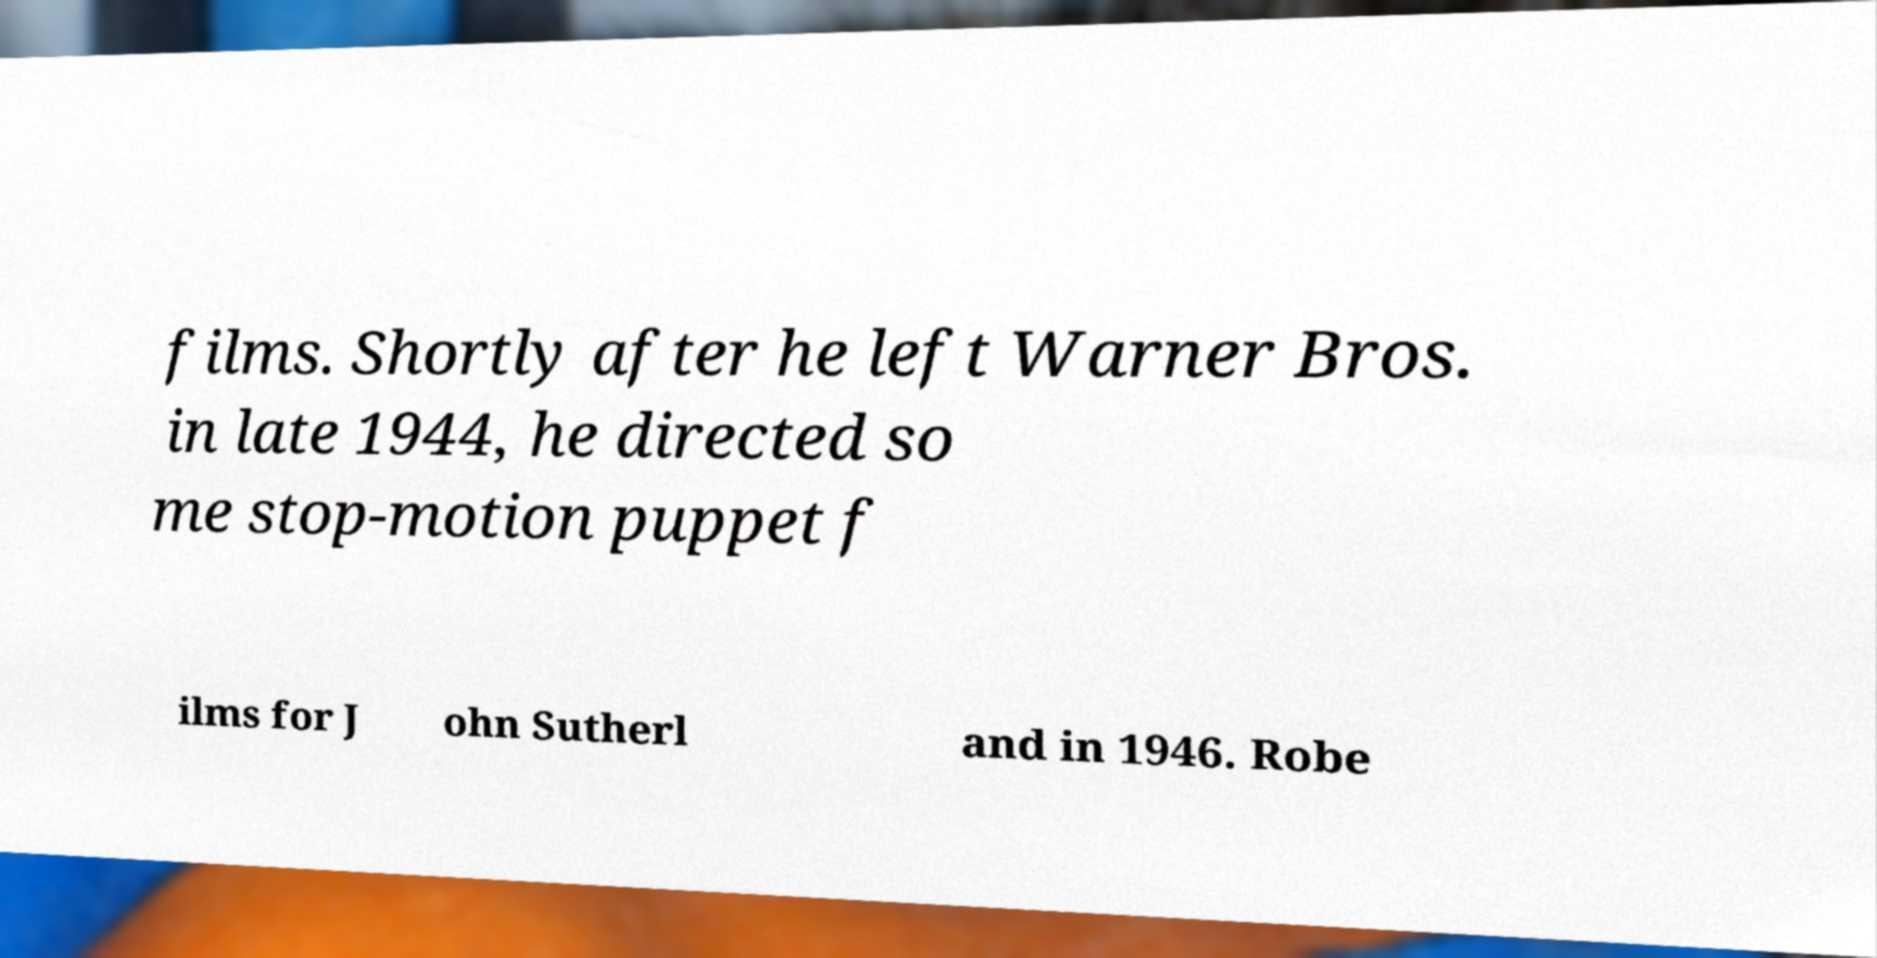Please identify and transcribe the text found in this image. films. Shortly after he left Warner Bros. in late 1944, he directed so me stop-motion puppet f ilms for J ohn Sutherl and in 1946. Robe 